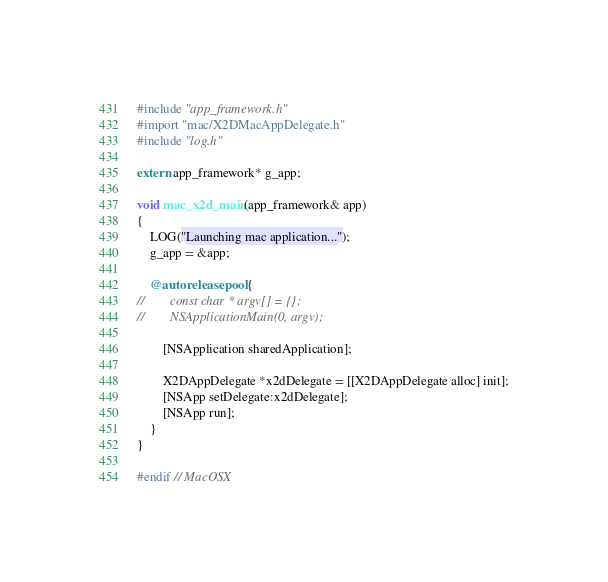Convert code to text. <code><loc_0><loc_0><loc_500><loc_500><_ObjectiveC_>
#include "app_framework.h"
#import "mac/X2DMacAppDelegate.h"
#include "log.h"

extern app_framework* g_app;

void mac_x2d_main(app_framework& app)
{
    LOG("Launching mac application...");
    g_app = &app;
    
    @autoreleasepool {
//        const char * argv[] = {};
//        NSApplicationMain(0, argv);
        
        [NSApplication sharedApplication];
        
        X2DAppDelegate *x2dDelegate = [[X2DAppDelegate alloc] init];
        [NSApp setDelegate:x2dDelegate];
        [NSApp run];
    }
}

#endif // MacOSX</code> 